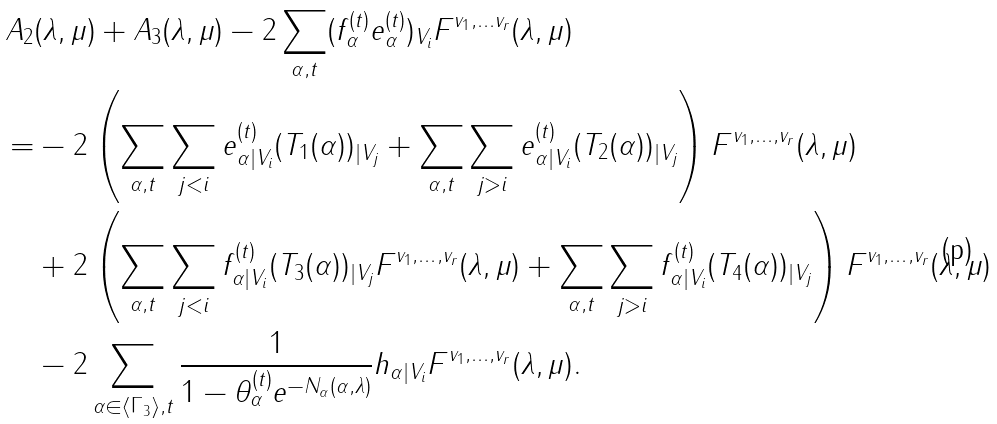Convert formula to latex. <formula><loc_0><loc_0><loc_500><loc_500>A _ { 2 } & ( \lambda , \mu ) + A _ { 3 } ( \lambda , \mu ) - 2 \sum _ { \alpha , t } ( f _ { \alpha } ^ { ( t ) } e _ { \alpha } ^ { ( t ) } ) _ { V _ { i } } F ^ { v _ { 1 } , \dots v _ { r } } ( \lambda , \mu ) \\ = & - 2 \left ( \sum _ { \alpha , t } \sum _ { j < i } e ^ { ( t ) } _ { \alpha | V _ { i } } ( T _ { 1 } ( \alpha ) ) _ { | V _ { j } } + \sum _ { \alpha , t } \sum _ { j > i } e ^ { ( t ) } _ { \alpha | V _ { i } } ( T _ { 2 } ( \alpha ) ) _ { | V _ { j } } \right ) F ^ { v _ { 1 } , \dots , v _ { r } } ( \lambda , \mu ) \\ & + 2 \left ( \sum _ { \alpha , t } \sum _ { j < i } f ^ { ( t ) } _ { \alpha | V _ { i } } ( T _ { 3 } ( \alpha ) ) _ { | V _ { j } } F ^ { v _ { 1 } , \dots , v _ { r } } ( \lambda , \mu ) + \sum _ { \alpha , t } \sum _ { j > i } f ^ { ( t ) } _ { \alpha | V _ { i } } ( T _ { 4 } ( \alpha ) ) _ { | V _ { j } } \right ) F ^ { v _ { 1 } , \dots , v _ { r } } ( \lambda , \mu ) \\ & - 2 \sum _ { \alpha \in \langle \Gamma _ { 3 } \rangle , t } \frac { 1 } { 1 - \theta _ { \alpha } ^ { ( t ) } e ^ { - N _ { \alpha } ( \alpha , \lambda ) } } h _ { \alpha | V _ { i } } F ^ { v _ { 1 } , \dots , v _ { r } } ( \lambda , \mu ) .</formula> 